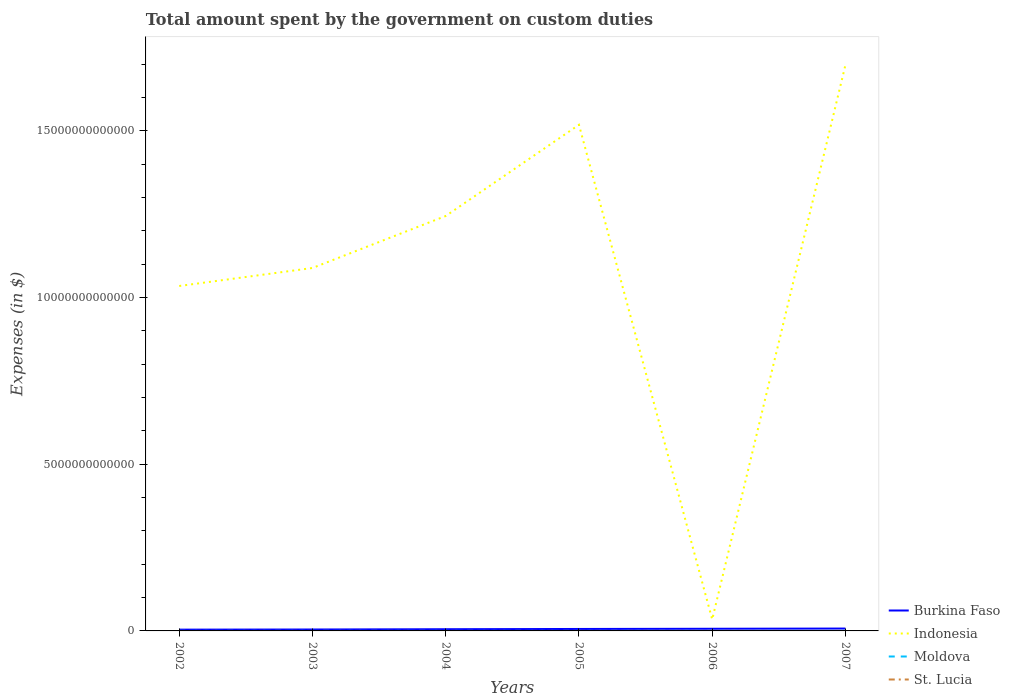Is the number of lines equal to the number of legend labels?
Offer a terse response. Yes. Across all years, what is the maximum amount spent on custom duties by the government in Burkina Faso?
Offer a terse response. 3.83e+1. What is the total amount spent on custom duties by the government in St. Lucia in the graph?
Keep it short and to the point. -7.83e+07. What is the difference between the highest and the second highest amount spent on custom duties by the government in St. Lucia?
Your response must be concise. 9.06e+07. What is the difference between the highest and the lowest amount spent on custom duties by the government in Burkina Faso?
Your response must be concise. 3. Is the amount spent on custom duties by the government in St. Lucia strictly greater than the amount spent on custom duties by the government in Indonesia over the years?
Offer a terse response. Yes. How many lines are there?
Ensure brevity in your answer.  4. How many years are there in the graph?
Keep it short and to the point. 6. What is the difference between two consecutive major ticks on the Y-axis?
Your response must be concise. 5.00e+12. Are the values on the major ticks of Y-axis written in scientific E-notation?
Your response must be concise. No. Does the graph contain grids?
Provide a short and direct response. No. How are the legend labels stacked?
Provide a succinct answer. Vertical. What is the title of the graph?
Offer a terse response. Total amount spent by the government on custom duties. Does "Turks and Caicos Islands" appear as one of the legend labels in the graph?
Make the answer very short. No. What is the label or title of the Y-axis?
Provide a short and direct response. Expenses (in $). What is the Expenses (in $) of Burkina Faso in 2002?
Keep it short and to the point. 3.83e+1. What is the Expenses (in $) of Indonesia in 2002?
Your answer should be very brief. 1.03e+13. What is the Expenses (in $) in Moldova in 2002?
Provide a succinct answer. 2.70e+08. What is the Expenses (in $) of St. Lucia in 2002?
Your response must be concise. 8.15e+07. What is the Expenses (in $) of Burkina Faso in 2003?
Make the answer very short. 4.25e+1. What is the Expenses (in $) of Indonesia in 2003?
Your answer should be very brief. 1.09e+13. What is the Expenses (in $) in Moldova in 2003?
Provide a short and direct response. 3.98e+08. What is the Expenses (in $) in St. Lucia in 2003?
Your answer should be very brief. 1.07e+08. What is the Expenses (in $) of Burkina Faso in 2004?
Offer a very short reply. 5.10e+1. What is the Expenses (in $) of Indonesia in 2004?
Your answer should be very brief. 1.24e+13. What is the Expenses (in $) in Moldova in 2004?
Provide a short and direct response. 4.17e+08. What is the Expenses (in $) in St. Lucia in 2004?
Offer a terse response. 1.17e+08. What is the Expenses (in $) of Burkina Faso in 2005?
Provide a short and direct response. 5.85e+1. What is the Expenses (in $) of Indonesia in 2005?
Your answer should be very brief. 1.52e+13. What is the Expenses (in $) in Moldova in 2005?
Your answer should be compact. 6.85e+08. What is the Expenses (in $) of St. Lucia in 2005?
Give a very brief answer. 1.36e+08. What is the Expenses (in $) in Burkina Faso in 2006?
Provide a succinct answer. 6.46e+1. What is the Expenses (in $) in Indonesia in 2006?
Your answer should be compact. 3.45e+11. What is the Expenses (in $) in Moldova in 2006?
Ensure brevity in your answer.  6.37e+08. What is the Expenses (in $) in St. Lucia in 2006?
Offer a very short reply. 1.60e+08. What is the Expenses (in $) in Burkina Faso in 2007?
Your answer should be very brief. 7.13e+1. What is the Expenses (in $) in Indonesia in 2007?
Offer a very short reply. 1.70e+13. What is the Expenses (in $) of Moldova in 2007?
Provide a short and direct response. 8.38e+08. What is the Expenses (in $) of St. Lucia in 2007?
Keep it short and to the point. 1.72e+08. Across all years, what is the maximum Expenses (in $) of Burkina Faso?
Your response must be concise. 7.13e+1. Across all years, what is the maximum Expenses (in $) in Indonesia?
Your answer should be very brief. 1.70e+13. Across all years, what is the maximum Expenses (in $) of Moldova?
Give a very brief answer. 8.38e+08. Across all years, what is the maximum Expenses (in $) in St. Lucia?
Ensure brevity in your answer.  1.72e+08. Across all years, what is the minimum Expenses (in $) of Burkina Faso?
Keep it short and to the point. 3.83e+1. Across all years, what is the minimum Expenses (in $) of Indonesia?
Provide a succinct answer. 3.45e+11. Across all years, what is the minimum Expenses (in $) in Moldova?
Ensure brevity in your answer.  2.70e+08. Across all years, what is the minimum Expenses (in $) of St. Lucia?
Your answer should be compact. 8.15e+07. What is the total Expenses (in $) of Burkina Faso in the graph?
Your answer should be very brief. 3.26e+11. What is the total Expenses (in $) of Indonesia in the graph?
Your answer should be compact. 6.62e+13. What is the total Expenses (in $) of Moldova in the graph?
Your response must be concise. 3.25e+09. What is the total Expenses (in $) of St. Lucia in the graph?
Offer a terse response. 7.73e+08. What is the difference between the Expenses (in $) in Burkina Faso in 2002 and that in 2003?
Your answer should be very brief. -4.20e+09. What is the difference between the Expenses (in $) of Indonesia in 2002 and that in 2003?
Ensure brevity in your answer.  -5.40e+11. What is the difference between the Expenses (in $) in Moldova in 2002 and that in 2003?
Offer a terse response. -1.28e+08. What is the difference between the Expenses (in $) in St. Lucia in 2002 and that in 2003?
Your answer should be compact. -2.55e+07. What is the difference between the Expenses (in $) in Burkina Faso in 2002 and that in 2004?
Ensure brevity in your answer.  -1.27e+1. What is the difference between the Expenses (in $) in Indonesia in 2002 and that in 2004?
Give a very brief answer. -2.10e+12. What is the difference between the Expenses (in $) of Moldova in 2002 and that in 2004?
Provide a succinct answer. -1.46e+08. What is the difference between the Expenses (in $) of St. Lucia in 2002 and that in 2004?
Ensure brevity in your answer.  -3.53e+07. What is the difference between the Expenses (in $) of Burkina Faso in 2002 and that in 2005?
Ensure brevity in your answer.  -2.03e+1. What is the difference between the Expenses (in $) of Indonesia in 2002 and that in 2005?
Offer a very short reply. -4.83e+12. What is the difference between the Expenses (in $) of Moldova in 2002 and that in 2005?
Your response must be concise. -4.15e+08. What is the difference between the Expenses (in $) of St. Lucia in 2002 and that in 2005?
Offer a terse response. -5.43e+07. What is the difference between the Expenses (in $) of Burkina Faso in 2002 and that in 2006?
Make the answer very short. -2.63e+1. What is the difference between the Expenses (in $) in Indonesia in 2002 and that in 2006?
Give a very brief answer. 1.00e+13. What is the difference between the Expenses (in $) in Moldova in 2002 and that in 2006?
Make the answer very short. -3.67e+08. What is the difference between the Expenses (in $) of St. Lucia in 2002 and that in 2006?
Offer a terse response. -7.83e+07. What is the difference between the Expenses (in $) in Burkina Faso in 2002 and that in 2007?
Your response must be concise. -3.30e+1. What is the difference between the Expenses (in $) in Indonesia in 2002 and that in 2007?
Provide a short and direct response. -6.63e+12. What is the difference between the Expenses (in $) of Moldova in 2002 and that in 2007?
Give a very brief answer. -5.68e+08. What is the difference between the Expenses (in $) of St. Lucia in 2002 and that in 2007?
Your answer should be very brief. -9.06e+07. What is the difference between the Expenses (in $) of Burkina Faso in 2003 and that in 2004?
Your response must be concise. -8.54e+09. What is the difference between the Expenses (in $) in Indonesia in 2003 and that in 2004?
Offer a very short reply. -1.56e+12. What is the difference between the Expenses (in $) in Moldova in 2003 and that in 2004?
Offer a terse response. -1.88e+07. What is the difference between the Expenses (in $) in St. Lucia in 2003 and that in 2004?
Offer a very short reply. -9.80e+06. What is the difference between the Expenses (in $) of Burkina Faso in 2003 and that in 2005?
Offer a very short reply. -1.61e+1. What is the difference between the Expenses (in $) in Indonesia in 2003 and that in 2005?
Provide a short and direct response. -4.29e+12. What is the difference between the Expenses (in $) of Moldova in 2003 and that in 2005?
Keep it short and to the point. -2.87e+08. What is the difference between the Expenses (in $) in St. Lucia in 2003 and that in 2005?
Provide a short and direct response. -2.88e+07. What is the difference between the Expenses (in $) of Burkina Faso in 2003 and that in 2006?
Offer a terse response. -2.21e+1. What is the difference between the Expenses (in $) in Indonesia in 2003 and that in 2006?
Your answer should be compact. 1.05e+13. What is the difference between the Expenses (in $) of Moldova in 2003 and that in 2006?
Provide a short and direct response. -2.40e+08. What is the difference between the Expenses (in $) in St. Lucia in 2003 and that in 2006?
Provide a succinct answer. -5.28e+07. What is the difference between the Expenses (in $) in Burkina Faso in 2003 and that in 2007?
Offer a very short reply. -2.88e+1. What is the difference between the Expenses (in $) of Indonesia in 2003 and that in 2007?
Offer a terse response. -6.09e+12. What is the difference between the Expenses (in $) of Moldova in 2003 and that in 2007?
Give a very brief answer. -4.41e+08. What is the difference between the Expenses (in $) of St. Lucia in 2003 and that in 2007?
Give a very brief answer. -6.51e+07. What is the difference between the Expenses (in $) of Burkina Faso in 2004 and that in 2005?
Offer a very short reply. -7.51e+09. What is the difference between the Expenses (in $) of Indonesia in 2004 and that in 2005?
Ensure brevity in your answer.  -2.74e+12. What is the difference between the Expenses (in $) in Moldova in 2004 and that in 2005?
Your answer should be very brief. -2.68e+08. What is the difference between the Expenses (in $) in St. Lucia in 2004 and that in 2005?
Make the answer very short. -1.90e+07. What is the difference between the Expenses (in $) in Burkina Faso in 2004 and that in 2006?
Offer a terse response. -1.36e+1. What is the difference between the Expenses (in $) of Indonesia in 2004 and that in 2006?
Offer a terse response. 1.21e+13. What is the difference between the Expenses (in $) of Moldova in 2004 and that in 2006?
Make the answer very short. -2.21e+08. What is the difference between the Expenses (in $) in St. Lucia in 2004 and that in 2006?
Make the answer very short. -4.30e+07. What is the difference between the Expenses (in $) in Burkina Faso in 2004 and that in 2007?
Make the answer very short. -2.03e+1. What is the difference between the Expenses (in $) of Indonesia in 2004 and that in 2007?
Your answer should be very brief. -4.53e+12. What is the difference between the Expenses (in $) of Moldova in 2004 and that in 2007?
Provide a short and direct response. -4.22e+08. What is the difference between the Expenses (in $) in St. Lucia in 2004 and that in 2007?
Keep it short and to the point. -5.53e+07. What is the difference between the Expenses (in $) of Burkina Faso in 2005 and that in 2006?
Offer a very short reply. -6.06e+09. What is the difference between the Expenses (in $) in Indonesia in 2005 and that in 2006?
Your answer should be compact. 1.48e+13. What is the difference between the Expenses (in $) in Moldova in 2005 and that in 2006?
Ensure brevity in your answer.  4.76e+07. What is the difference between the Expenses (in $) of St. Lucia in 2005 and that in 2006?
Your answer should be compact. -2.40e+07. What is the difference between the Expenses (in $) in Burkina Faso in 2005 and that in 2007?
Your answer should be compact. -1.28e+1. What is the difference between the Expenses (in $) of Indonesia in 2005 and that in 2007?
Your answer should be compact. -1.80e+12. What is the difference between the Expenses (in $) of Moldova in 2005 and that in 2007?
Make the answer very short. -1.54e+08. What is the difference between the Expenses (in $) in St. Lucia in 2005 and that in 2007?
Offer a terse response. -3.63e+07. What is the difference between the Expenses (in $) in Burkina Faso in 2006 and that in 2007?
Ensure brevity in your answer.  -6.70e+09. What is the difference between the Expenses (in $) in Indonesia in 2006 and that in 2007?
Offer a terse response. -1.66e+13. What is the difference between the Expenses (in $) in Moldova in 2006 and that in 2007?
Give a very brief answer. -2.01e+08. What is the difference between the Expenses (in $) in St. Lucia in 2006 and that in 2007?
Provide a short and direct response. -1.23e+07. What is the difference between the Expenses (in $) of Burkina Faso in 2002 and the Expenses (in $) of Indonesia in 2003?
Give a very brief answer. -1.08e+13. What is the difference between the Expenses (in $) in Burkina Faso in 2002 and the Expenses (in $) in Moldova in 2003?
Your answer should be compact. 3.79e+1. What is the difference between the Expenses (in $) in Burkina Faso in 2002 and the Expenses (in $) in St. Lucia in 2003?
Your response must be concise. 3.82e+1. What is the difference between the Expenses (in $) of Indonesia in 2002 and the Expenses (in $) of Moldova in 2003?
Ensure brevity in your answer.  1.03e+13. What is the difference between the Expenses (in $) in Indonesia in 2002 and the Expenses (in $) in St. Lucia in 2003?
Make the answer very short. 1.03e+13. What is the difference between the Expenses (in $) in Moldova in 2002 and the Expenses (in $) in St. Lucia in 2003?
Make the answer very short. 1.63e+08. What is the difference between the Expenses (in $) in Burkina Faso in 2002 and the Expenses (in $) in Indonesia in 2004?
Make the answer very short. -1.24e+13. What is the difference between the Expenses (in $) in Burkina Faso in 2002 and the Expenses (in $) in Moldova in 2004?
Your answer should be very brief. 3.79e+1. What is the difference between the Expenses (in $) in Burkina Faso in 2002 and the Expenses (in $) in St. Lucia in 2004?
Make the answer very short. 3.82e+1. What is the difference between the Expenses (in $) in Indonesia in 2002 and the Expenses (in $) in Moldova in 2004?
Your answer should be compact. 1.03e+13. What is the difference between the Expenses (in $) of Indonesia in 2002 and the Expenses (in $) of St. Lucia in 2004?
Offer a very short reply. 1.03e+13. What is the difference between the Expenses (in $) in Moldova in 2002 and the Expenses (in $) in St. Lucia in 2004?
Offer a very short reply. 1.54e+08. What is the difference between the Expenses (in $) in Burkina Faso in 2002 and the Expenses (in $) in Indonesia in 2005?
Offer a very short reply. -1.51e+13. What is the difference between the Expenses (in $) of Burkina Faso in 2002 and the Expenses (in $) of Moldova in 2005?
Provide a succinct answer. 3.76e+1. What is the difference between the Expenses (in $) of Burkina Faso in 2002 and the Expenses (in $) of St. Lucia in 2005?
Offer a very short reply. 3.82e+1. What is the difference between the Expenses (in $) of Indonesia in 2002 and the Expenses (in $) of Moldova in 2005?
Your response must be concise. 1.03e+13. What is the difference between the Expenses (in $) of Indonesia in 2002 and the Expenses (in $) of St. Lucia in 2005?
Provide a succinct answer. 1.03e+13. What is the difference between the Expenses (in $) in Moldova in 2002 and the Expenses (in $) in St. Lucia in 2005?
Provide a succinct answer. 1.35e+08. What is the difference between the Expenses (in $) of Burkina Faso in 2002 and the Expenses (in $) of Indonesia in 2006?
Your response must be concise. -3.06e+11. What is the difference between the Expenses (in $) of Burkina Faso in 2002 and the Expenses (in $) of Moldova in 2006?
Keep it short and to the point. 3.77e+1. What is the difference between the Expenses (in $) in Burkina Faso in 2002 and the Expenses (in $) in St. Lucia in 2006?
Your response must be concise. 3.81e+1. What is the difference between the Expenses (in $) of Indonesia in 2002 and the Expenses (in $) of Moldova in 2006?
Ensure brevity in your answer.  1.03e+13. What is the difference between the Expenses (in $) in Indonesia in 2002 and the Expenses (in $) in St. Lucia in 2006?
Ensure brevity in your answer.  1.03e+13. What is the difference between the Expenses (in $) in Moldova in 2002 and the Expenses (in $) in St. Lucia in 2006?
Ensure brevity in your answer.  1.11e+08. What is the difference between the Expenses (in $) of Burkina Faso in 2002 and the Expenses (in $) of Indonesia in 2007?
Give a very brief answer. -1.69e+13. What is the difference between the Expenses (in $) in Burkina Faso in 2002 and the Expenses (in $) in Moldova in 2007?
Keep it short and to the point. 3.75e+1. What is the difference between the Expenses (in $) of Burkina Faso in 2002 and the Expenses (in $) of St. Lucia in 2007?
Your response must be concise. 3.81e+1. What is the difference between the Expenses (in $) in Indonesia in 2002 and the Expenses (in $) in Moldova in 2007?
Offer a terse response. 1.03e+13. What is the difference between the Expenses (in $) in Indonesia in 2002 and the Expenses (in $) in St. Lucia in 2007?
Ensure brevity in your answer.  1.03e+13. What is the difference between the Expenses (in $) in Moldova in 2002 and the Expenses (in $) in St. Lucia in 2007?
Provide a short and direct response. 9.83e+07. What is the difference between the Expenses (in $) in Burkina Faso in 2003 and the Expenses (in $) in Indonesia in 2004?
Your answer should be very brief. -1.24e+13. What is the difference between the Expenses (in $) of Burkina Faso in 2003 and the Expenses (in $) of Moldova in 2004?
Ensure brevity in your answer.  4.21e+1. What is the difference between the Expenses (in $) of Burkina Faso in 2003 and the Expenses (in $) of St. Lucia in 2004?
Offer a very short reply. 4.24e+1. What is the difference between the Expenses (in $) in Indonesia in 2003 and the Expenses (in $) in Moldova in 2004?
Your answer should be compact. 1.09e+13. What is the difference between the Expenses (in $) of Indonesia in 2003 and the Expenses (in $) of St. Lucia in 2004?
Your response must be concise. 1.09e+13. What is the difference between the Expenses (in $) of Moldova in 2003 and the Expenses (in $) of St. Lucia in 2004?
Provide a succinct answer. 2.81e+08. What is the difference between the Expenses (in $) in Burkina Faso in 2003 and the Expenses (in $) in Indonesia in 2005?
Provide a succinct answer. -1.51e+13. What is the difference between the Expenses (in $) in Burkina Faso in 2003 and the Expenses (in $) in Moldova in 2005?
Offer a very short reply. 4.18e+1. What is the difference between the Expenses (in $) of Burkina Faso in 2003 and the Expenses (in $) of St. Lucia in 2005?
Give a very brief answer. 4.24e+1. What is the difference between the Expenses (in $) in Indonesia in 2003 and the Expenses (in $) in Moldova in 2005?
Your answer should be compact. 1.09e+13. What is the difference between the Expenses (in $) of Indonesia in 2003 and the Expenses (in $) of St. Lucia in 2005?
Your response must be concise. 1.09e+13. What is the difference between the Expenses (in $) of Moldova in 2003 and the Expenses (in $) of St. Lucia in 2005?
Provide a succinct answer. 2.62e+08. What is the difference between the Expenses (in $) in Burkina Faso in 2003 and the Expenses (in $) in Indonesia in 2006?
Your answer should be compact. -3.02e+11. What is the difference between the Expenses (in $) of Burkina Faso in 2003 and the Expenses (in $) of Moldova in 2006?
Ensure brevity in your answer.  4.19e+1. What is the difference between the Expenses (in $) in Burkina Faso in 2003 and the Expenses (in $) in St. Lucia in 2006?
Keep it short and to the point. 4.23e+1. What is the difference between the Expenses (in $) of Indonesia in 2003 and the Expenses (in $) of Moldova in 2006?
Offer a terse response. 1.09e+13. What is the difference between the Expenses (in $) in Indonesia in 2003 and the Expenses (in $) in St. Lucia in 2006?
Make the answer very short. 1.09e+13. What is the difference between the Expenses (in $) of Moldova in 2003 and the Expenses (in $) of St. Lucia in 2006?
Offer a very short reply. 2.38e+08. What is the difference between the Expenses (in $) of Burkina Faso in 2003 and the Expenses (in $) of Indonesia in 2007?
Ensure brevity in your answer.  -1.69e+13. What is the difference between the Expenses (in $) in Burkina Faso in 2003 and the Expenses (in $) in Moldova in 2007?
Provide a short and direct response. 4.17e+1. What is the difference between the Expenses (in $) in Burkina Faso in 2003 and the Expenses (in $) in St. Lucia in 2007?
Your answer should be very brief. 4.23e+1. What is the difference between the Expenses (in $) in Indonesia in 2003 and the Expenses (in $) in Moldova in 2007?
Keep it short and to the point. 1.09e+13. What is the difference between the Expenses (in $) in Indonesia in 2003 and the Expenses (in $) in St. Lucia in 2007?
Your answer should be very brief. 1.09e+13. What is the difference between the Expenses (in $) in Moldova in 2003 and the Expenses (in $) in St. Lucia in 2007?
Offer a very short reply. 2.26e+08. What is the difference between the Expenses (in $) of Burkina Faso in 2004 and the Expenses (in $) of Indonesia in 2005?
Give a very brief answer. -1.51e+13. What is the difference between the Expenses (in $) in Burkina Faso in 2004 and the Expenses (in $) in Moldova in 2005?
Offer a very short reply. 5.03e+1. What is the difference between the Expenses (in $) of Burkina Faso in 2004 and the Expenses (in $) of St. Lucia in 2005?
Ensure brevity in your answer.  5.09e+1. What is the difference between the Expenses (in $) in Indonesia in 2004 and the Expenses (in $) in Moldova in 2005?
Keep it short and to the point. 1.24e+13. What is the difference between the Expenses (in $) of Indonesia in 2004 and the Expenses (in $) of St. Lucia in 2005?
Provide a succinct answer. 1.24e+13. What is the difference between the Expenses (in $) of Moldova in 2004 and the Expenses (in $) of St. Lucia in 2005?
Your response must be concise. 2.81e+08. What is the difference between the Expenses (in $) of Burkina Faso in 2004 and the Expenses (in $) of Indonesia in 2006?
Ensure brevity in your answer.  -2.94e+11. What is the difference between the Expenses (in $) in Burkina Faso in 2004 and the Expenses (in $) in Moldova in 2006?
Make the answer very short. 5.04e+1. What is the difference between the Expenses (in $) of Burkina Faso in 2004 and the Expenses (in $) of St. Lucia in 2006?
Ensure brevity in your answer.  5.09e+1. What is the difference between the Expenses (in $) of Indonesia in 2004 and the Expenses (in $) of Moldova in 2006?
Provide a succinct answer. 1.24e+13. What is the difference between the Expenses (in $) in Indonesia in 2004 and the Expenses (in $) in St. Lucia in 2006?
Provide a short and direct response. 1.24e+13. What is the difference between the Expenses (in $) of Moldova in 2004 and the Expenses (in $) of St. Lucia in 2006?
Ensure brevity in your answer.  2.57e+08. What is the difference between the Expenses (in $) in Burkina Faso in 2004 and the Expenses (in $) in Indonesia in 2007?
Give a very brief answer. -1.69e+13. What is the difference between the Expenses (in $) in Burkina Faso in 2004 and the Expenses (in $) in Moldova in 2007?
Give a very brief answer. 5.02e+1. What is the difference between the Expenses (in $) in Burkina Faso in 2004 and the Expenses (in $) in St. Lucia in 2007?
Give a very brief answer. 5.09e+1. What is the difference between the Expenses (in $) of Indonesia in 2004 and the Expenses (in $) of Moldova in 2007?
Provide a short and direct response. 1.24e+13. What is the difference between the Expenses (in $) of Indonesia in 2004 and the Expenses (in $) of St. Lucia in 2007?
Your answer should be very brief. 1.24e+13. What is the difference between the Expenses (in $) in Moldova in 2004 and the Expenses (in $) in St. Lucia in 2007?
Provide a short and direct response. 2.45e+08. What is the difference between the Expenses (in $) of Burkina Faso in 2005 and the Expenses (in $) of Indonesia in 2006?
Provide a succinct answer. -2.86e+11. What is the difference between the Expenses (in $) in Burkina Faso in 2005 and the Expenses (in $) in Moldova in 2006?
Your answer should be very brief. 5.79e+1. What is the difference between the Expenses (in $) of Burkina Faso in 2005 and the Expenses (in $) of St. Lucia in 2006?
Your answer should be very brief. 5.84e+1. What is the difference between the Expenses (in $) of Indonesia in 2005 and the Expenses (in $) of Moldova in 2006?
Ensure brevity in your answer.  1.52e+13. What is the difference between the Expenses (in $) in Indonesia in 2005 and the Expenses (in $) in St. Lucia in 2006?
Offer a terse response. 1.52e+13. What is the difference between the Expenses (in $) in Moldova in 2005 and the Expenses (in $) in St. Lucia in 2006?
Keep it short and to the point. 5.25e+08. What is the difference between the Expenses (in $) in Burkina Faso in 2005 and the Expenses (in $) in Indonesia in 2007?
Offer a terse response. -1.69e+13. What is the difference between the Expenses (in $) in Burkina Faso in 2005 and the Expenses (in $) in Moldova in 2007?
Make the answer very short. 5.77e+1. What is the difference between the Expenses (in $) of Burkina Faso in 2005 and the Expenses (in $) of St. Lucia in 2007?
Your answer should be compact. 5.84e+1. What is the difference between the Expenses (in $) in Indonesia in 2005 and the Expenses (in $) in Moldova in 2007?
Offer a very short reply. 1.52e+13. What is the difference between the Expenses (in $) of Indonesia in 2005 and the Expenses (in $) of St. Lucia in 2007?
Give a very brief answer. 1.52e+13. What is the difference between the Expenses (in $) in Moldova in 2005 and the Expenses (in $) in St. Lucia in 2007?
Ensure brevity in your answer.  5.13e+08. What is the difference between the Expenses (in $) in Burkina Faso in 2006 and the Expenses (in $) in Indonesia in 2007?
Your answer should be very brief. -1.69e+13. What is the difference between the Expenses (in $) of Burkina Faso in 2006 and the Expenses (in $) of Moldova in 2007?
Offer a terse response. 6.38e+1. What is the difference between the Expenses (in $) of Burkina Faso in 2006 and the Expenses (in $) of St. Lucia in 2007?
Provide a succinct answer. 6.44e+1. What is the difference between the Expenses (in $) in Indonesia in 2006 and the Expenses (in $) in Moldova in 2007?
Your response must be concise. 3.44e+11. What is the difference between the Expenses (in $) of Indonesia in 2006 and the Expenses (in $) of St. Lucia in 2007?
Keep it short and to the point. 3.45e+11. What is the difference between the Expenses (in $) in Moldova in 2006 and the Expenses (in $) in St. Lucia in 2007?
Ensure brevity in your answer.  4.65e+08. What is the average Expenses (in $) of Burkina Faso per year?
Keep it short and to the point. 5.44e+1. What is the average Expenses (in $) of Indonesia per year?
Give a very brief answer. 1.10e+13. What is the average Expenses (in $) in Moldova per year?
Make the answer very short. 5.41e+08. What is the average Expenses (in $) in St. Lucia per year?
Your answer should be compact. 1.29e+08. In the year 2002, what is the difference between the Expenses (in $) of Burkina Faso and Expenses (in $) of Indonesia?
Offer a terse response. -1.03e+13. In the year 2002, what is the difference between the Expenses (in $) of Burkina Faso and Expenses (in $) of Moldova?
Offer a terse response. 3.80e+1. In the year 2002, what is the difference between the Expenses (in $) of Burkina Faso and Expenses (in $) of St. Lucia?
Offer a terse response. 3.82e+1. In the year 2002, what is the difference between the Expenses (in $) in Indonesia and Expenses (in $) in Moldova?
Make the answer very short. 1.03e+13. In the year 2002, what is the difference between the Expenses (in $) in Indonesia and Expenses (in $) in St. Lucia?
Your answer should be very brief. 1.03e+13. In the year 2002, what is the difference between the Expenses (in $) of Moldova and Expenses (in $) of St. Lucia?
Provide a succinct answer. 1.89e+08. In the year 2003, what is the difference between the Expenses (in $) of Burkina Faso and Expenses (in $) of Indonesia?
Make the answer very short. -1.08e+13. In the year 2003, what is the difference between the Expenses (in $) of Burkina Faso and Expenses (in $) of Moldova?
Provide a short and direct response. 4.21e+1. In the year 2003, what is the difference between the Expenses (in $) in Burkina Faso and Expenses (in $) in St. Lucia?
Your response must be concise. 4.24e+1. In the year 2003, what is the difference between the Expenses (in $) of Indonesia and Expenses (in $) of Moldova?
Provide a short and direct response. 1.09e+13. In the year 2003, what is the difference between the Expenses (in $) in Indonesia and Expenses (in $) in St. Lucia?
Keep it short and to the point. 1.09e+13. In the year 2003, what is the difference between the Expenses (in $) of Moldova and Expenses (in $) of St. Lucia?
Your answer should be very brief. 2.91e+08. In the year 2004, what is the difference between the Expenses (in $) in Burkina Faso and Expenses (in $) in Indonesia?
Ensure brevity in your answer.  -1.24e+13. In the year 2004, what is the difference between the Expenses (in $) in Burkina Faso and Expenses (in $) in Moldova?
Give a very brief answer. 5.06e+1. In the year 2004, what is the difference between the Expenses (in $) of Burkina Faso and Expenses (in $) of St. Lucia?
Ensure brevity in your answer.  5.09e+1. In the year 2004, what is the difference between the Expenses (in $) in Indonesia and Expenses (in $) in Moldova?
Ensure brevity in your answer.  1.24e+13. In the year 2004, what is the difference between the Expenses (in $) of Indonesia and Expenses (in $) of St. Lucia?
Offer a very short reply. 1.24e+13. In the year 2004, what is the difference between the Expenses (in $) in Moldova and Expenses (in $) in St. Lucia?
Make the answer very short. 3.00e+08. In the year 2005, what is the difference between the Expenses (in $) of Burkina Faso and Expenses (in $) of Indonesia?
Keep it short and to the point. -1.51e+13. In the year 2005, what is the difference between the Expenses (in $) of Burkina Faso and Expenses (in $) of Moldova?
Offer a very short reply. 5.79e+1. In the year 2005, what is the difference between the Expenses (in $) of Burkina Faso and Expenses (in $) of St. Lucia?
Your answer should be very brief. 5.84e+1. In the year 2005, what is the difference between the Expenses (in $) of Indonesia and Expenses (in $) of Moldova?
Make the answer very short. 1.52e+13. In the year 2005, what is the difference between the Expenses (in $) of Indonesia and Expenses (in $) of St. Lucia?
Keep it short and to the point. 1.52e+13. In the year 2005, what is the difference between the Expenses (in $) in Moldova and Expenses (in $) in St. Lucia?
Make the answer very short. 5.49e+08. In the year 2006, what is the difference between the Expenses (in $) in Burkina Faso and Expenses (in $) in Indonesia?
Give a very brief answer. -2.80e+11. In the year 2006, what is the difference between the Expenses (in $) in Burkina Faso and Expenses (in $) in Moldova?
Ensure brevity in your answer.  6.40e+1. In the year 2006, what is the difference between the Expenses (in $) in Burkina Faso and Expenses (in $) in St. Lucia?
Offer a terse response. 6.44e+1. In the year 2006, what is the difference between the Expenses (in $) in Indonesia and Expenses (in $) in Moldova?
Make the answer very short. 3.44e+11. In the year 2006, what is the difference between the Expenses (in $) in Indonesia and Expenses (in $) in St. Lucia?
Provide a short and direct response. 3.45e+11. In the year 2006, what is the difference between the Expenses (in $) in Moldova and Expenses (in $) in St. Lucia?
Give a very brief answer. 4.78e+08. In the year 2007, what is the difference between the Expenses (in $) of Burkina Faso and Expenses (in $) of Indonesia?
Provide a succinct answer. -1.69e+13. In the year 2007, what is the difference between the Expenses (in $) of Burkina Faso and Expenses (in $) of Moldova?
Make the answer very short. 7.05e+1. In the year 2007, what is the difference between the Expenses (in $) in Burkina Faso and Expenses (in $) in St. Lucia?
Provide a short and direct response. 7.11e+1. In the year 2007, what is the difference between the Expenses (in $) in Indonesia and Expenses (in $) in Moldova?
Offer a terse response. 1.70e+13. In the year 2007, what is the difference between the Expenses (in $) of Indonesia and Expenses (in $) of St. Lucia?
Offer a terse response. 1.70e+13. In the year 2007, what is the difference between the Expenses (in $) of Moldova and Expenses (in $) of St. Lucia?
Ensure brevity in your answer.  6.66e+08. What is the ratio of the Expenses (in $) of Burkina Faso in 2002 to that in 2003?
Give a very brief answer. 0.9. What is the ratio of the Expenses (in $) in Indonesia in 2002 to that in 2003?
Offer a terse response. 0.95. What is the ratio of the Expenses (in $) in Moldova in 2002 to that in 2003?
Provide a succinct answer. 0.68. What is the ratio of the Expenses (in $) of St. Lucia in 2002 to that in 2003?
Offer a terse response. 0.76. What is the ratio of the Expenses (in $) of Burkina Faso in 2002 to that in 2004?
Ensure brevity in your answer.  0.75. What is the ratio of the Expenses (in $) in Indonesia in 2002 to that in 2004?
Provide a succinct answer. 0.83. What is the ratio of the Expenses (in $) of Moldova in 2002 to that in 2004?
Offer a terse response. 0.65. What is the ratio of the Expenses (in $) in St. Lucia in 2002 to that in 2004?
Provide a short and direct response. 0.7. What is the ratio of the Expenses (in $) of Burkina Faso in 2002 to that in 2005?
Your answer should be compact. 0.65. What is the ratio of the Expenses (in $) of Indonesia in 2002 to that in 2005?
Give a very brief answer. 0.68. What is the ratio of the Expenses (in $) in Moldova in 2002 to that in 2005?
Provide a short and direct response. 0.39. What is the ratio of the Expenses (in $) in St. Lucia in 2002 to that in 2005?
Your response must be concise. 0.6. What is the ratio of the Expenses (in $) in Burkina Faso in 2002 to that in 2006?
Make the answer very short. 0.59. What is the ratio of the Expenses (in $) of Indonesia in 2002 to that in 2006?
Make the answer very short. 30.01. What is the ratio of the Expenses (in $) in Moldova in 2002 to that in 2006?
Keep it short and to the point. 0.42. What is the ratio of the Expenses (in $) in St. Lucia in 2002 to that in 2006?
Ensure brevity in your answer.  0.51. What is the ratio of the Expenses (in $) in Burkina Faso in 2002 to that in 2007?
Give a very brief answer. 0.54. What is the ratio of the Expenses (in $) in Indonesia in 2002 to that in 2007?
Your answer should be very brief. 0.61. What is the ratio of the Expenses (in $) of Moldova in 2002 to that in 2007?
Offer a terse response. 0.32. What is the ratio of the Expenses (in $) in St. Lucia in 2002 to that in 2007?
Your answer should be compact. 0.47. What is the ratio of the Expenses (in $) of Burkina Faso in 2003 to that in 2004?
Ensure brevity in your answer.  0.83. What is the ratio of the Expenses (in $) of Indonesia in 2003 to that in 2004?
Make the answer very short. 0.87. What is the ratio of the Expenses (in $) of Moldova in 2003 to that in 2004?
Your response must be concise. 0.95. What is the ratio of the Expenses (in $) in St. Lucia in 2003 to that in 2004?
Keep it short and to the point. 0.92. What is the ratio of the Expenses (in $) in Burkina Faso in 2003 to that in 2005?
Provide a succinct answer. 0.73. What is the ratio of the Expenses (in $) of Indonesia in 2003 to that in 2005?
Your response must be concise. 0.72. What is the ratio of the Expenses (in $) of Moldova in 2003 to that in 2005?
Ensure brevity in your answer.  0.58. What is the ratio of the Expenses (in $) of St. Lucia in 2003 to that in 2005?
Your response must be concise. 0.79. What is the ratio of the Expenses (in $) of Burkina Faso in 2003 to that in 2006?
Your answer should be very brief. 0.66. What is the ratio of the Expenses (in $) of Indonesia in 2003 to that in 2006?
Offer a terse response. 31.58. What is the ratio of the Expenses (in $) in Moldova in 2003 to that in 2006?
Provide a succinct answer. 0.62. What is the ratio of the Expenses (in $) of St. Lucia in 2003 to that in 2006?
Keep it short and to the point. 0.67. What is the ratio of the Expenses (in $) in Burkina Faso in 2003 to that in 2007?
Make the answer very short. 0.6. What is the ratio of the Expenses (in $) in Indonesia in 2003 to that in 2007?
Provide a succinct answer. 0.64. What is the ratio of the Expenses (in $) of Moldova in 2003 to that in 2007?
Give a very brief answer. 0.47. What is the ratio of the Expenses (in $) of St. Lucia in 2003 to that in 2007?
Keep it short and to the point. 0.62. What is the ratio of the Expenses (in $) in Burkina Faso in 2004 to that in 2005?
Your answer should be compact. 0.87. What is the ratio of the Expenses (in $) of Indonesia in 2004 to that in 2005?
Provide a short and direct response. 0.82. What is the ratio of the Expenses (in $) of Moldova in 2004 to that in 2005?
Your response must be concise. 0.61. What is the ratio of the Expenses (in $) of St. Lucia in 2004 to that in 2005?
Offer a very short reply. 0.86. What is the ratio of the Expenses (in $) in Burkina Faso in 2004 to that in 2006?
Your response must be concise. 0.79. What is the ratio of the Expenses (in $) of Indonesia in 2004 to that in 2006?
Keep it short and to the point. 36.1. What is the ratio of the Expenses (in $) of Moldova in 2004 to that in 2006?
Provide a short and direct response. 0.65. What is the ratio of the Expenses (in $) in St. Lucia in 2004 to that in 2006?
Make the answer very short. 0.73. What is the ratio of the Expenses (in $) of Burkina Faso in 2004 to that in 2007?
Your response must be concise. 0.72. What is the ratio of the Expenses (in $) of Indonesia in 2004 to that in 2007?
Give a very brief answer. 0.73. What is the ratio of the Expenses (in $) in Moldova in 2004 to that in 2007?
Provide a short and direct response. 0.5. What is the ratio of the Expenses (in $) in St. Lucia in 2004 to that in 2007?
Your answer should be compact. 0.68. What is the ratio of the Expenses (in $) in Burkina Faso in 2005 to that in 2006?
Your answer should be very brief. 0.91. What is the ratio of the Expenses (in $) of Indonesia in 2005 to that in 2006?
Give a very brief answer. 44.03. What is the ratio of the Expenses (in $) in Moldova in 2005 to that in 2006?
Your response must be concise. 1.07. What is the ratio of the Expenses (in $) of St. Lucia in 2005 to that in 2006?
Ensure brevity in your answer.  0.85. What is the ratio of the Expenses (in $) in Burkina Faso in 2005 to that in 2007?
Your answer should be compact. 0.82. What is the ratio of the Expenses (in $) of Indonesia in 2005 to that in 2007?
Offer a very short reply. 0.89. What is the ratio of the Expenses (in $) in Moldova in 2005 to that in 2007?
Offer a terse response. 0.82. What is the ratio of the Expenses (in $) of St. Lucia in 2005 to that in 2007?
Provide a succinct answer. 0.79. What is the ratio of the Expenses (in $) in Burkina Faso in 2006 to that in 2007?
Give a very brief answer. 0.91. What is the ratio of the Expenses (in $) of Indonesia in 2006 to that in 2007?
Provide a succinct answer. 0.02. What is the ratio of the Expenses (in $) in Moldova in 2006 to that in 2007?
Keep it short and to the point. 0.76. What is the ratio of the Expenses (in $) of St. Lucia in 2006 to that in 2007?
Your response must be concise. 0.93. What is the difference between the highest and the second highest Expenses (in $) in Burkina Faso?
Give a very brief answer. 6.70e+09. What is the difference between the highest and the second highest Expenses (in $) in Indonesia?
Offer a terse response. 1.80e+12. What is the difference between the highest and the second highest Expenses (in $) of Moldova?
Your response must be concise. 1.54e+08. What is the difference between the highest and the second highest Expenses (in $) in St. Lucia?
Your answer should be compact. 1.23e+07. What is the difference between the highest and the lowest Expenses (in $) in Burkina Faso?
Your answer should be compact. 3.30e+1. What is the difference between the highest and the lowest Expenses (in $) of Indonesia?
Keep it short and to the point. 1.66e+13. What is the difference between the highest and the lowest Expenses (in $) in Moldova?
Provide a succinct answer. 5.68e+08. What is the difference between the highest and the lowest Expenses (in $) in St. Lucia?
Keep it short and to the point. 9.06e+07. 